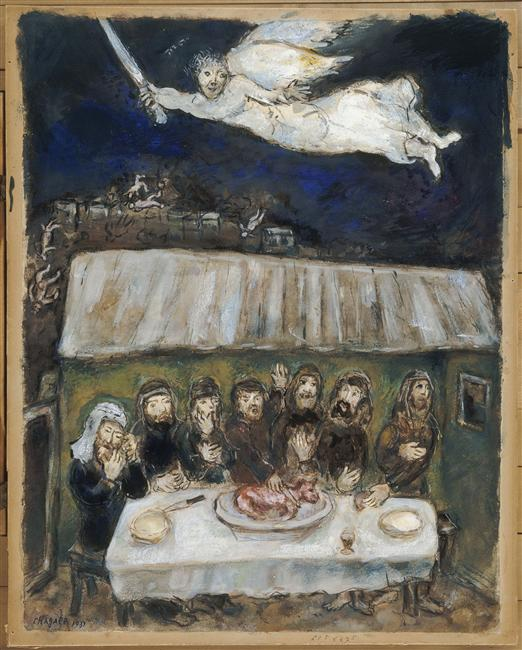What do the setting and background details tell us about the time and place of this scene? The rustic, simple architecture of the house and sparse, bleak landscape suggest a scene set in a rural or remote area, possibly in a historical or timeless setting. The dark, moody sky and bare trees add a touch of gloom and isolation, enhancing the painting's overall mood of mystique and anticipation. These elements might indicate the scene represents a moment outside of ordinary time, perhaps a mystical or spiritual encounter. 